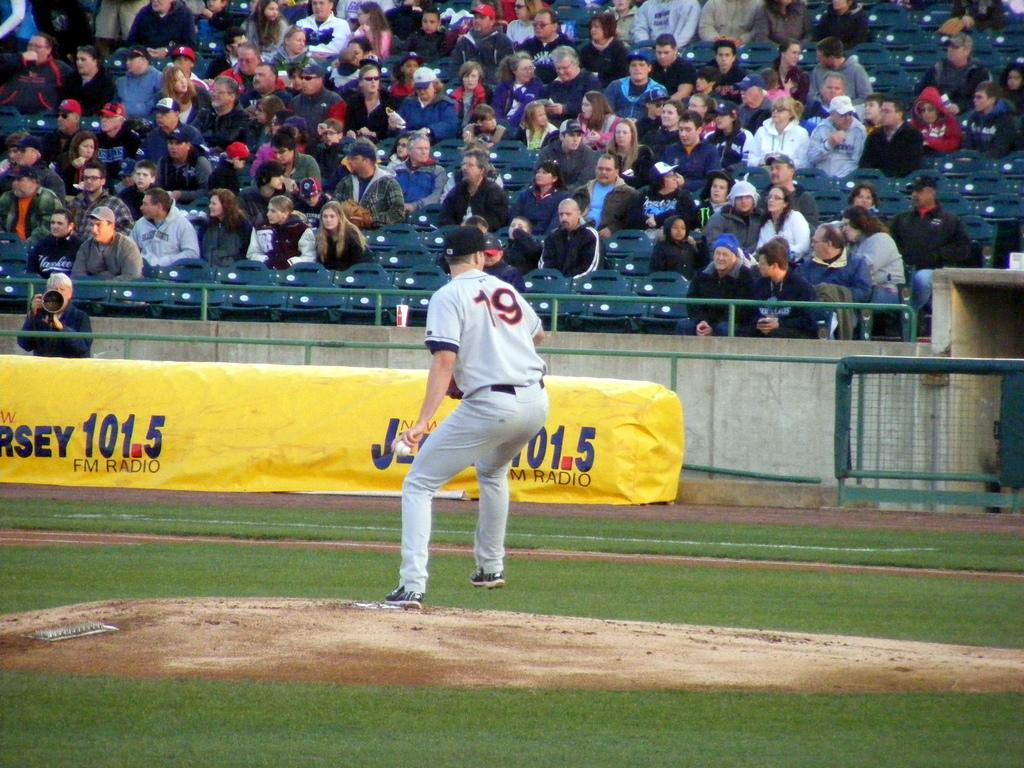<image>
Present a compact description of the photo's key features. pitcher #19 getting ready to throw in front of crowd with a banner showing for new jersey 101.5 fm radio 